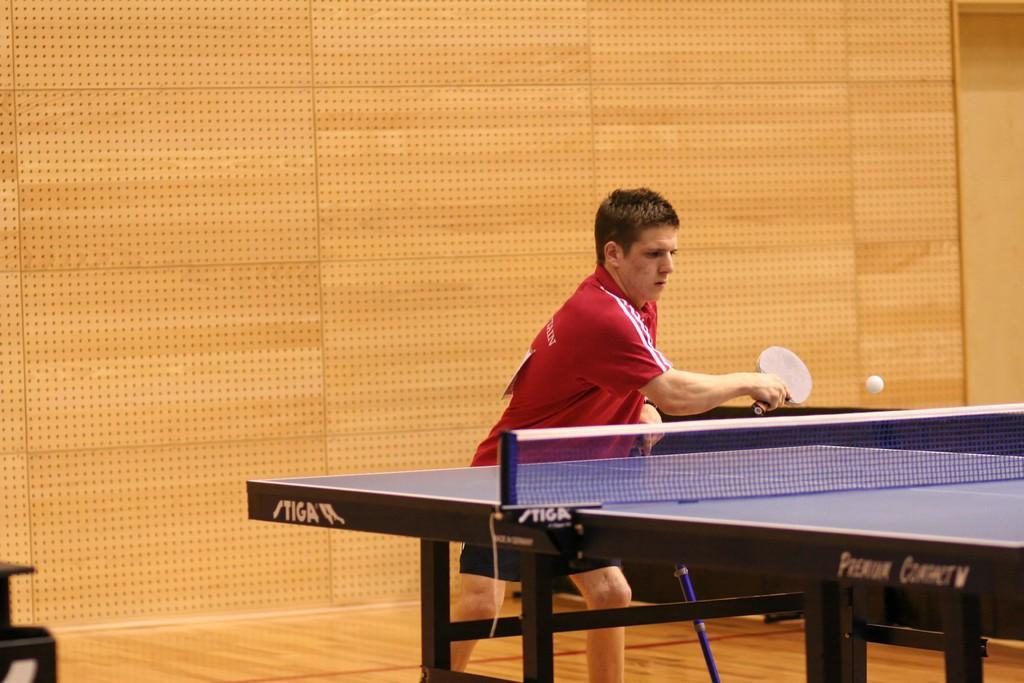What color is the t-shirt worn by the person in the image? The person is wearing a red t-shirt. What activity is the person engaged in? The person is playing table tennis. What equipment is being used in the game? A racket and a ball are being used in the game. What separates the two sides of the table tennis setup? There is a net in the table tennis setup. What is the color of the background in the image? The background color is light brown. What material is the floor made of? The floor is made of wood. How many horses are visible in the image? There are no horses present in the image. What type of growth is being observed in the image? There is no growth being observed in the image; it features a person playing table tennis. 